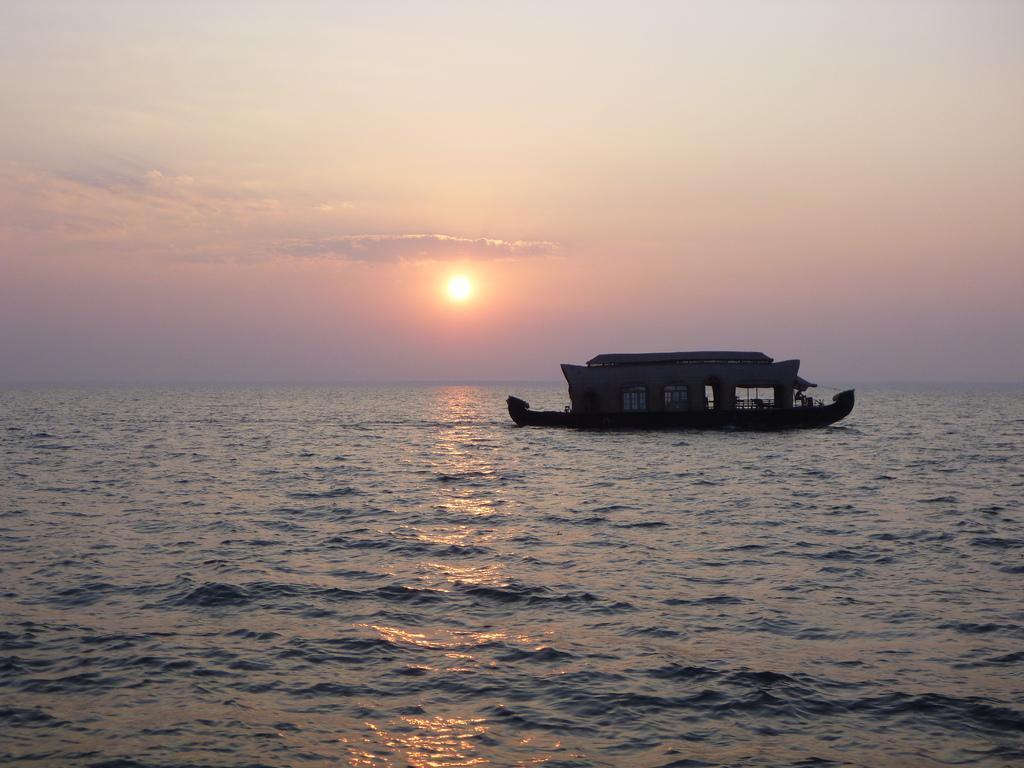What is the main subject of the image? The main subject of the image is water. What is located on the surface of the water? There is a boat on the surface of the water. What can be seen in the background of the image? The sky is visible in the background of the image. What celestial body is observable in the sky? The sun is observable in the sky. Where is the mine located in the image? There is no mine present in the image. What type of berry can be seen growing near the water's edge in the image? There are no berries present in the image. 